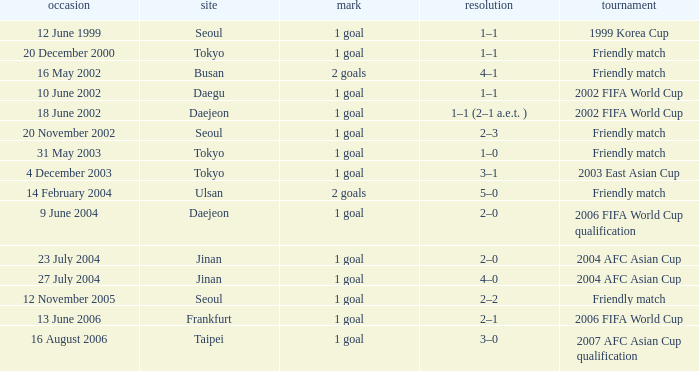Give me the full table as a dictionary. {'header': ['occasion', 'site', 'mark', 'resolution', 'tournament'], 'rows': [['12 June 1999', 'Seoul', '1 goal', '1–1', '1999 Korea Cup'], ['20 December 2000', 'Tokyo', '1 goal', '1–1', 'Friendly match'], ['16 May 2002', 'Busan', '2 goals', '4–1', 'Friendly match'], ['10 June 2002', 'Daegu', '1 goal', '1–1', '2002 FIFA World Cup'], ['18 June 2002', 'Daejeon', '1 goal', '1–1 (2–1 a.e.t. )', '2002 FIFA World Cup'], ['20 November 2002', 'Seoul', '1 goal', '2–3', 'Friendly match'], ['31 May 2003', 'Tokyo', '1 goal', '1–0', 'Friendly match'], ['4 December 2003', 'Tokyo', '1 goal', '3–1', '2003 East Asian Cup'], ['14 February 2004', 'Ulsan', '2 goals', '5–0', 'Friendly match'], ['9 June 2004', 'Daejeon', '1 goal', '2–0', '2006 FIFA World Cup qualification'], ['23 July 2004', 'Jinan', '1 goal', '2–0', '2004 AFC Asian Cup'], ['27 July 2004', 'Jinan', '1 goal', '4–0', '2004 AFC Asian Cup'], ['12 November 2005', 'Seoul', '1 goal', '2–2', 'Friendly match'], ['13 June 2006', 'Frankfurt', '1 goal', '2–1', '2006 FIFA World Cup'], ['16 August 2006', 'Taipei', '1 goal', '3–0', '2007 AFC Asian Cup qualification']]} What is the venue of the game on 20 November 2002? Seoul. 